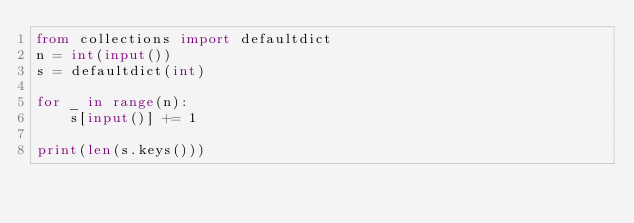Convert code to text. <code><loc_0><loc_0><loc_500><loc_500><_Python_>from collections import defaultdict
n = int(input())
s = defaultdict(int)

for _ in range(n):
    s[input()] += 1

print(len(s.keys()))</code> 